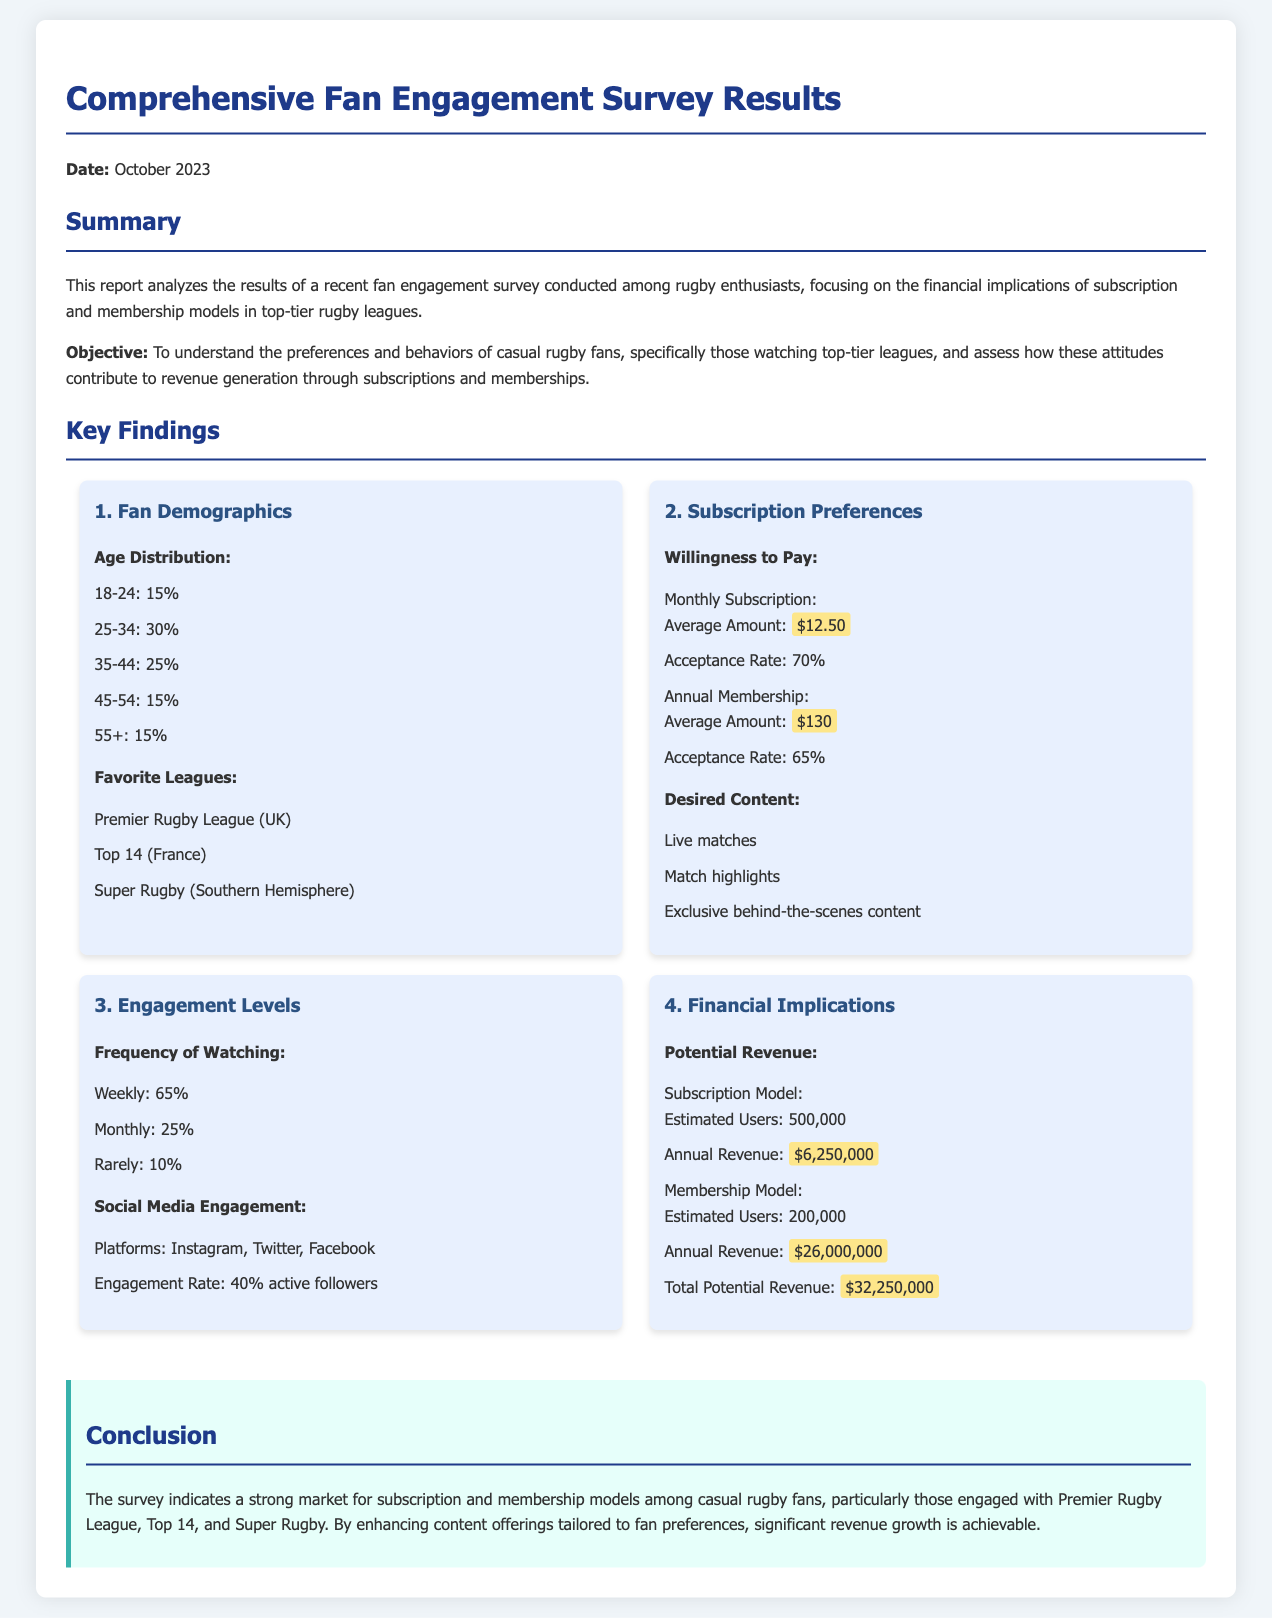What is the average monthly subscription amount preferred by fans? The document specifies that the average amount fans are willing to pay for a monthly subscription is $12.50.
Answer: $12.50 What is the estimated number of users for the membership model? According to the report, the estimated users for the membership model is stated as 200,000.
Answer: 200,000 What percentage of fans watch rugby weekly? The report highlights that 65% of fans watch rugby on a weekly basis.
Answer: 65% What is the total potential revenue from subscriptions and memberships? The total potential revenue is calculated from the subscription and membership models, totaling $32,250,000.
Answer: $32,250,000 What is the acceptance rate for the annual membership option? The document mentions that the acceptance rate for the annual membership is 65%.
Answer: 65% Which league is mentioned as a favorite among rugby fans? The report lists several favorites, one of which is the Premier Rugby League (UK).
Answer: Premier Rugby League (UK) What is the engagement rate of active followers on social media? The document states that the engagement rate of active followers on social media is 40%.
Answer: 40% What type of content do fans desire? The report indicates that fans desire live matches, match highlights, and exclusive behind-the-scenes content.
Answer: Live matches, match highlights, exclusive behind-the-scenes content 